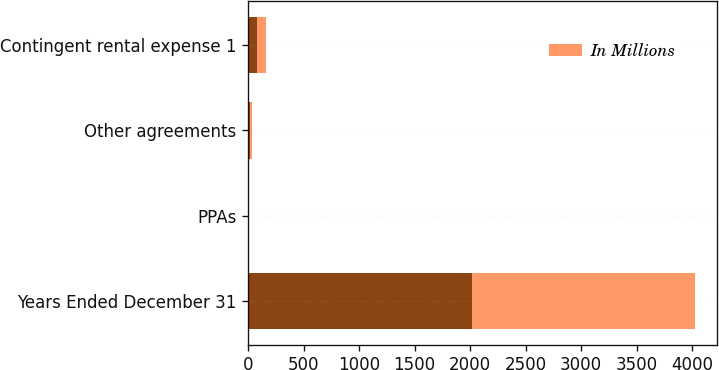<chart> <loc_0><loc_0><loc_500><loc_500><stacked_bar_chart><ecel><fcel>Years Ended December 31<fcel>PPAs<fcel>Other agreements<fcel>Contingent rental expense 1<nl><fcel>nan<fcel>2014<fcel>6<fcel>19<fcel>85<nl><fcel>In Millions<fcel>2013<fcel>6<fcel>21<fcel>77<nl></chart> 